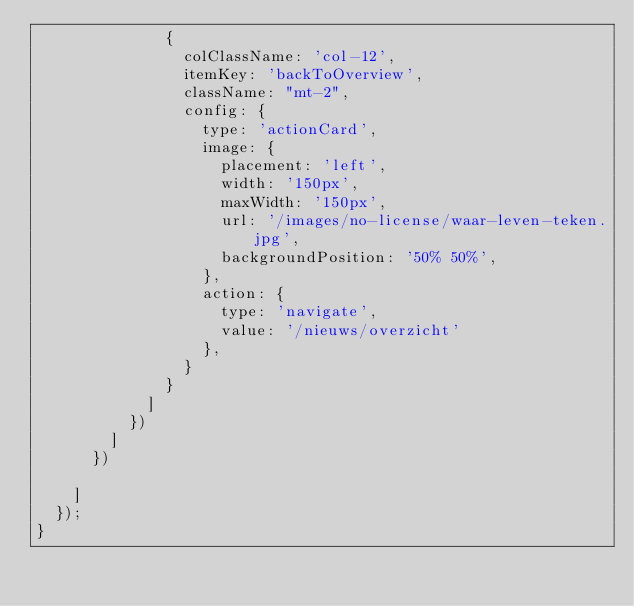<code> <loc_0><loc_0><loc_500><loc_500><_TypeScript_>              {
                colClassName: 'col-12',
                itemKey: 'backToOverview',
                className: "mt-2",
                config: {
                  type: 'actionCard',
                  image: {
                    placement: 'left',
                    width: '150px',
                    maxWidth: '150px',
                    url: '/images/no-license/waar-leven-teken.jpg',
                    backgroundPosition: '50% 50%',
                  },
                  action: {
                    type: 'navigate',
                    value: '/nieuws/overzicht'
                  },
                }
              }
            ]
          })
        ]
      })

    ]
  });
}
</code> 